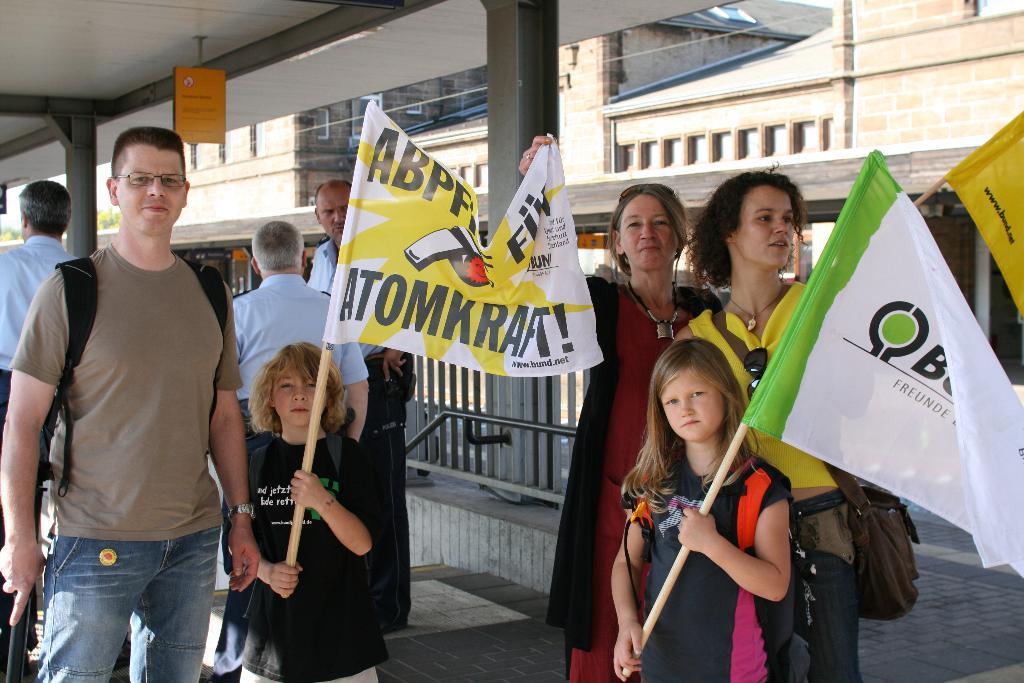In one or two sentences, can you explain what this image depicts? There are few persons standing where two kids among them are holding flags which are attached to a wooden stick in their hands. 